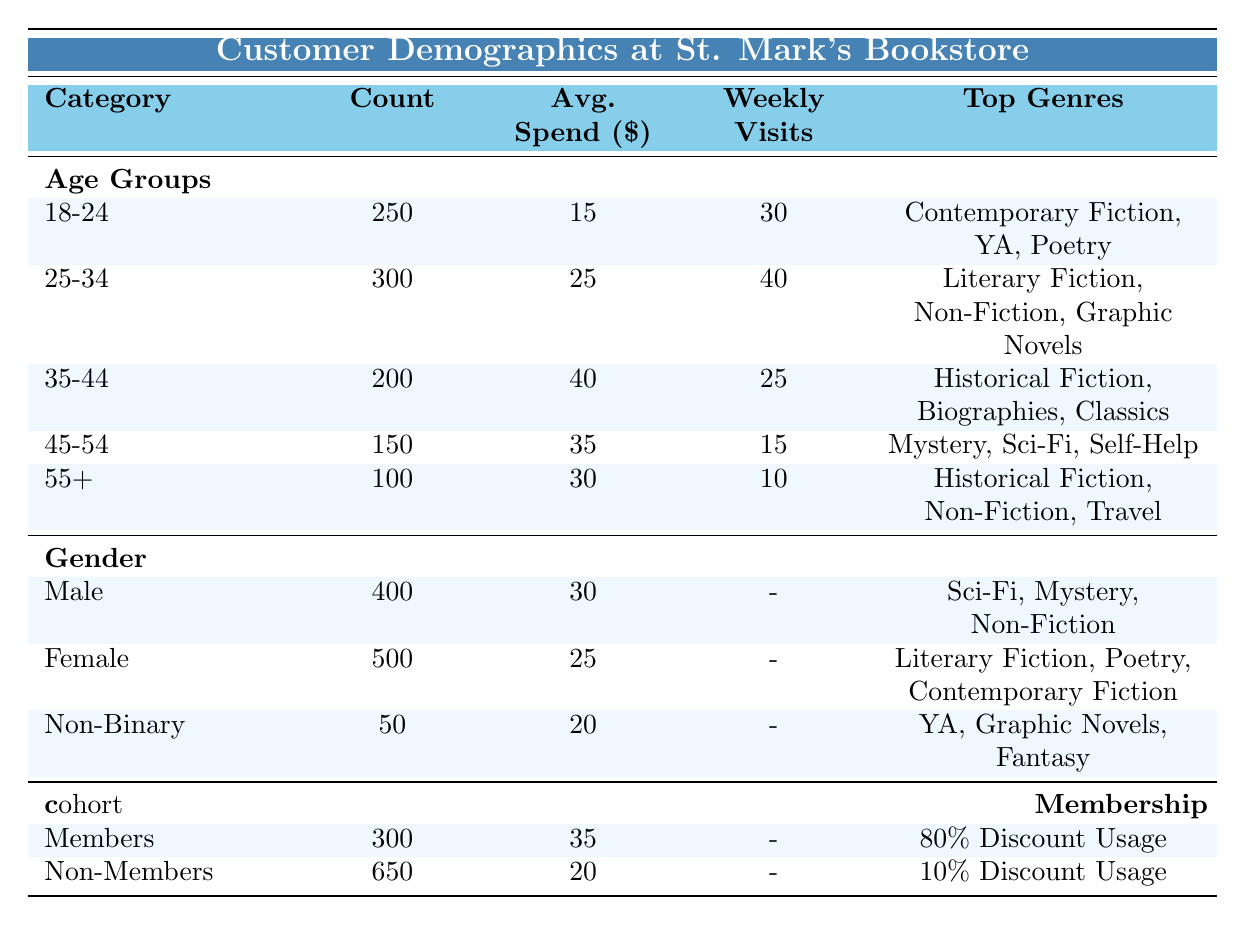What is the average spending of females at St. Mark's Bookstore? From the Gender Distribution section, the average spending for females is clearly stated as 25 dollars.
Answer: 25 How many customers fall within the age group of 45-54? The table explicitly shows the count for the age group of 45-54 is 150.
Answer: 150 Which age group spends the most on average? We compare the Average Spend across age groups: 18-24: 15, 25-34: 25, 35-44: 40, 45-54: 35, and 55+: 30. The highest value is 40 in the 35-44 age group.
Answer: 35-44 What percentage of members use discounts compared to non-members? Members have an 80% discount usage while non-members have a 10% discount usage. To compare: (80/10) = 8, showing that members use discounts 8 times more than non-members.
Answer: 8 times Is the number of non-binary customers greater than the number of customers aged 55 and above? There are 50 non-binary customers and 100 customers aged 55 and above. Since 100 is greater than 50, the statement is false.
Answer: No Which gender has a higher average spend and by how much? The average spending for males is 30 dollars, while for females it is 25 dollars. The difference is 30 - 25 = 5 dollars, meaning males spend 5 dollars more on average than females.
Answer: 5 dollars What is the total count of customers that are non-members? The count of non-members is stated as 650 in the Membership Status section. This is a direct retrieval from the table.
Answer: 650 How many customers aged 25-34 visit the store weekly? According to the table, the Weekly Visits for the age group 25-34 are 40.
Answer: 40 Which age group has the lowest average spending and what is that amount? The age group 18-24 has the lowest average spend at 15 dollars. This is clear from comparing all age groups listed in the table.
Answer: 15 